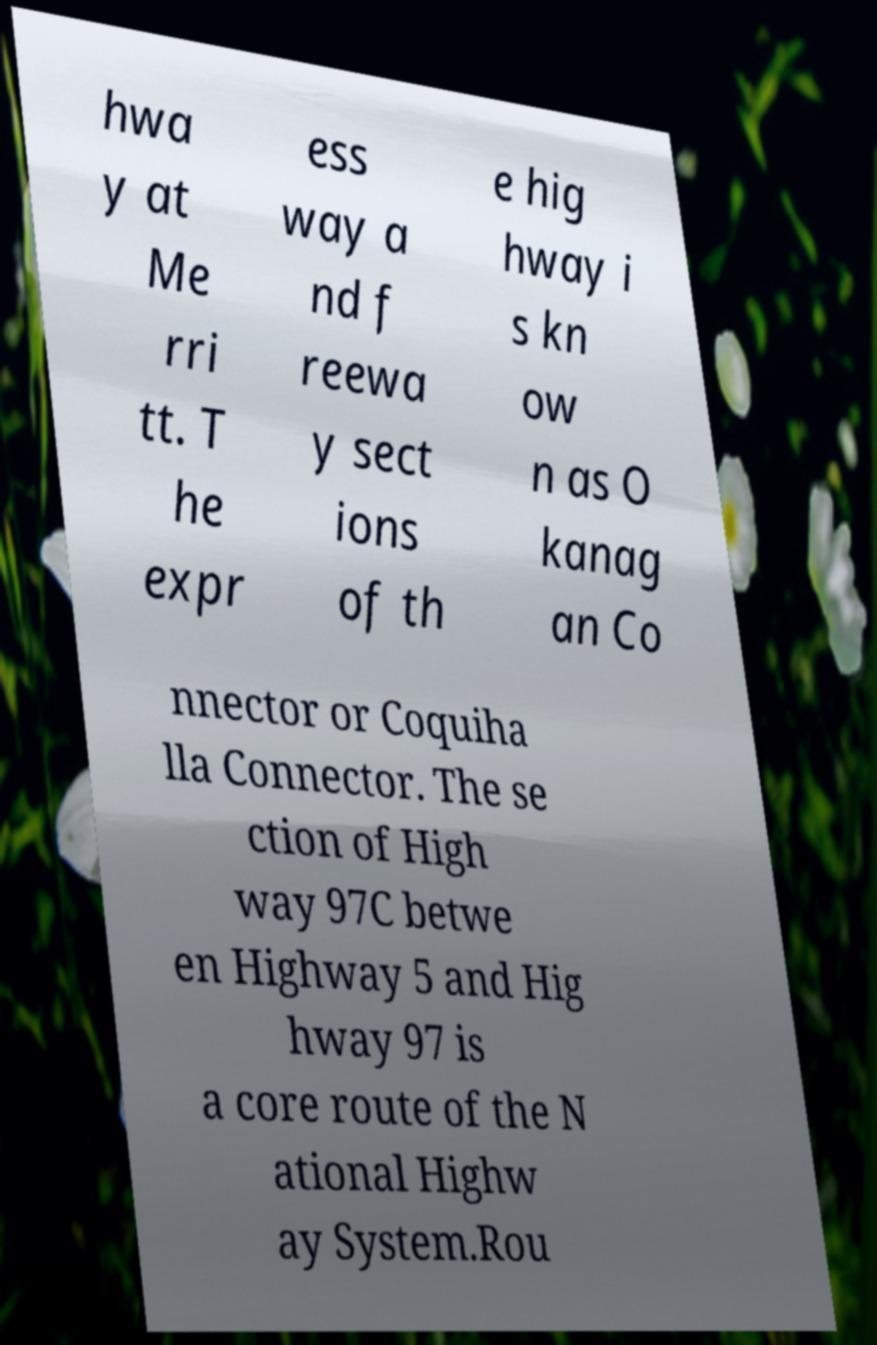I need the written content from this picture converted into text. Can you do that? hwa y at Me rri tt. T he expr ess way a nd f reewa y sect ions of th e hig hway i s kn ow n as O kanag an Co nnector or Coquiha lla Connector. The se ction of High way 97C betwe en Highway 5 and Hig hway 97 is a core route of the N ational Highw ay System.Rou 